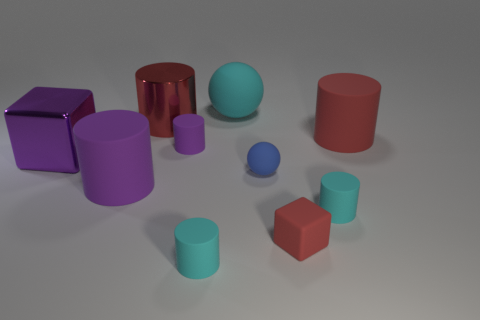What is the color of the big matte cylinder to the right of the purple rubber cylinder that is left of the big metallic cylinder?
Keep it short and to the point. Red. Is the large cyan sphere made of the same material as the small red thing?
Give a very brief answer. Yes. Is there another matte object that has the same shape as the blue thing?
Ensure brevity in your answer.  Yes. Is the color of the large shiny thing that is in front of the tiny purple rubber object the same as the big shiny cylinder?
Offer a terse response. No. There is a rubber object that is behind the red rubber cylinder; is its size the same as the purple rubber cylinder that is in front of the small blue matte sphere?
Provide a succinct answer. Yes. There is a blue thing that is the same material as the small red block; what size is it?
Provide a succinct answer. Small. How many things are both on the left side of the big red rubber thing and right of the tiny ball?
Offer a very short reply. 2. What number of things are tiny red shiny objects or big objects behind the big red metal cylinder?
Keep it short and to the point. 1. What is the shape of the large metallic thing that is the same color as the tiny rubber block?
Offer a terse response. Cylinder. There is a big thing right of the big cyan object; what color is it?
Your answer should be very brief. Red. 